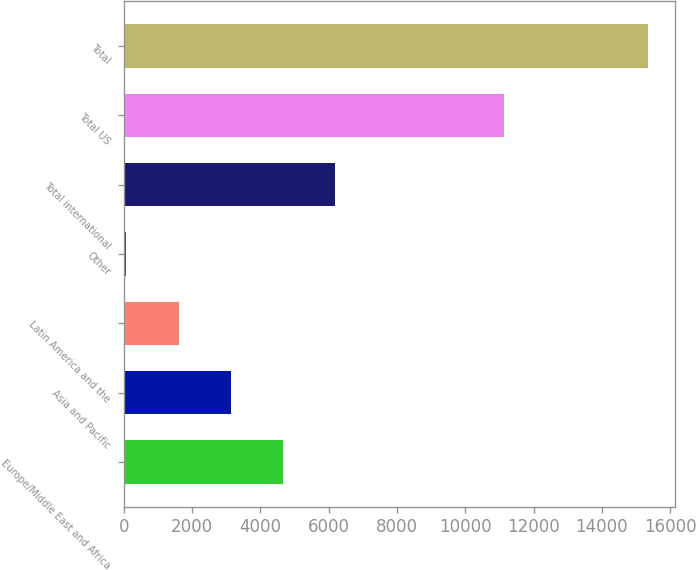Convert chart to OTSL. <chart><loc_0><loc_0><loc_500><loc_500><bar_chart><fcel>Europe/Middle East and Africa<fcel>Asia and Pacific<fcel>Latin America and the<fcel>Other<fcel>Total international<fcel>Total US<fcel>Total<nl><fcel>4664.8<fcel>3136.2<fcel>1607.6<fcel>79<fcel>6193.4<fcel>11126<fcel>15365<nl></chart> 